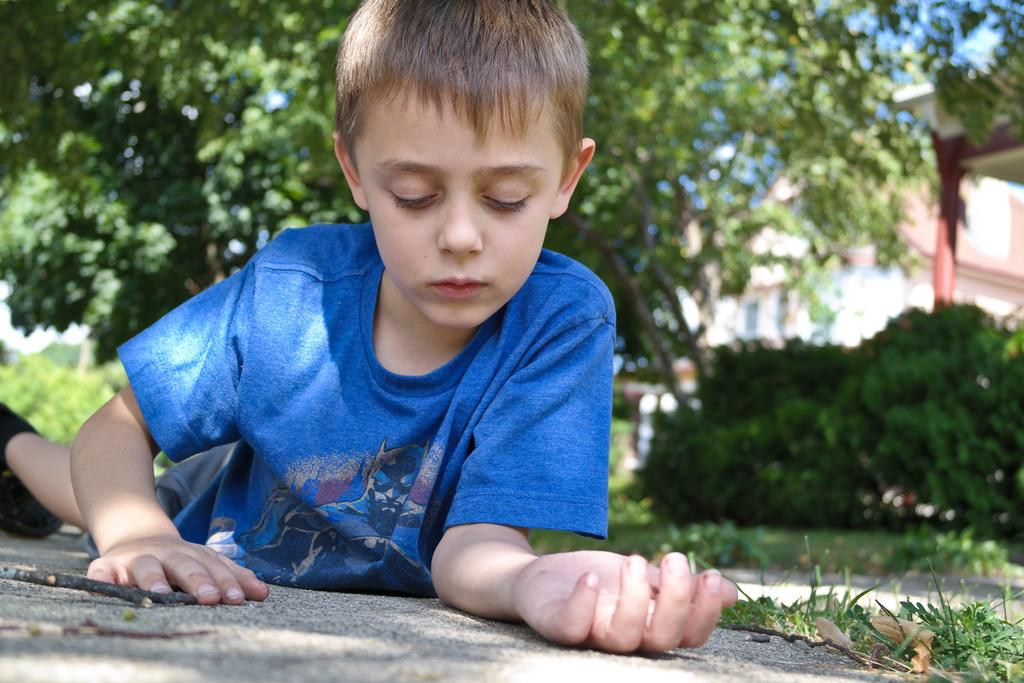Who is the main subject in the image? There is a boy in the image. What type of surface is the boy standing on? There is grass on the ground in the image. What can be seen in the background of the image? There are trees and a building in the background of the image. How is the building depicted in the image? The building is blurry in the background. What emotion is the boy expressing in the image? The image does not show any specific emotion being expressed by the boy. What type of learning material is the boy using in the image? There is no learning material present in the image. 